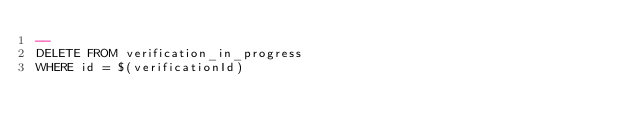<code> <loc_0><loc_0><loc_500><loc_500><_SQL_>--
DELETE FROM verification_in_progress
WHERE id = $(verificationId)
</code> 